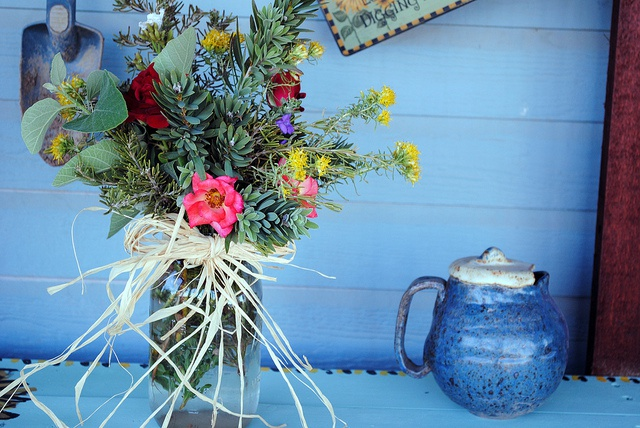Describe the objects in this image and their specific colors. I can see vase in lightblue, blue, darkgray, navy, and gray tones and vase in lightblue, gray, ivory, and black tones in this image. 